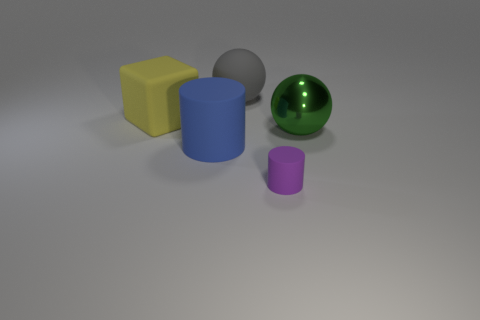Add 1 tiny purple matte cylinders. How many objects exist? 6 Subtract all gray spheres. How many spheres are left? 1 Subtract all large balls. Subtract all purple cylinders. How many objects are left? 2 Add 2 large blue rubber cylinders. How many large blue rubber cylinders are left? 3 Add 1 large blue objects. How many large blue objects exist? 2 Subtract 1 blue cylinders. How many objects are left? 4 Subtract all balls. How many objects are left? 3 Subtract 1 cylinders. How many cylinders are left? 1 Subtract all blue cubes. Subtract all purple cylinders. How many cubes are left? 1 Subtract all yellow cubes. How many green cylinders are left? 0 